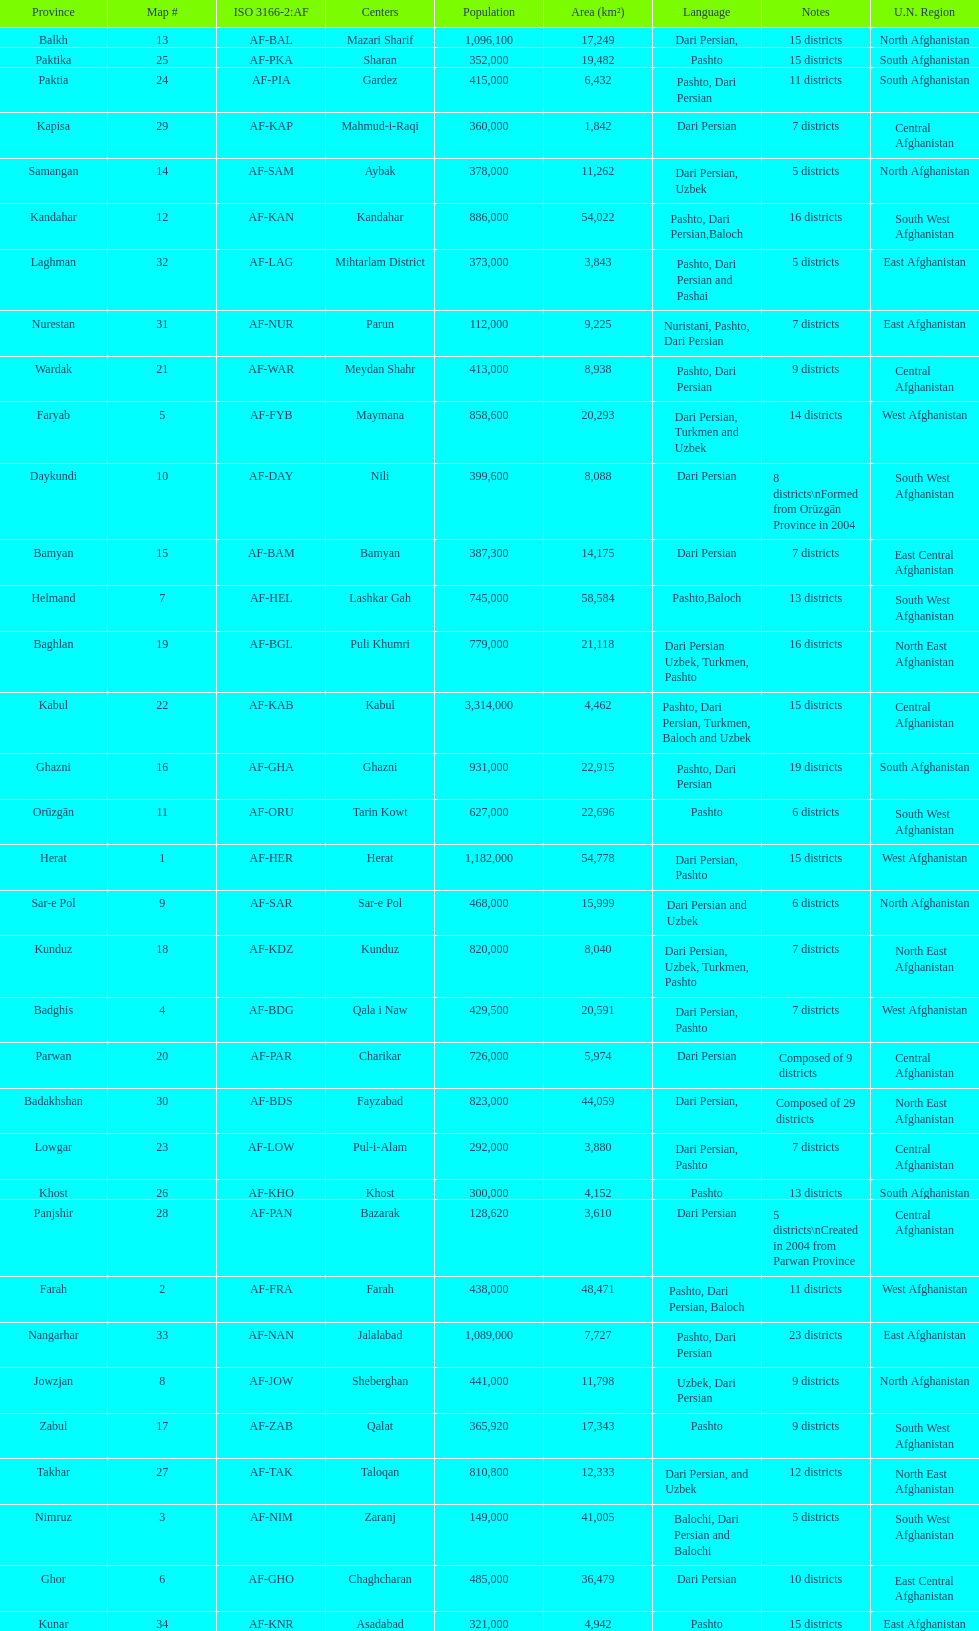Give the province with the least population Nurestan. 